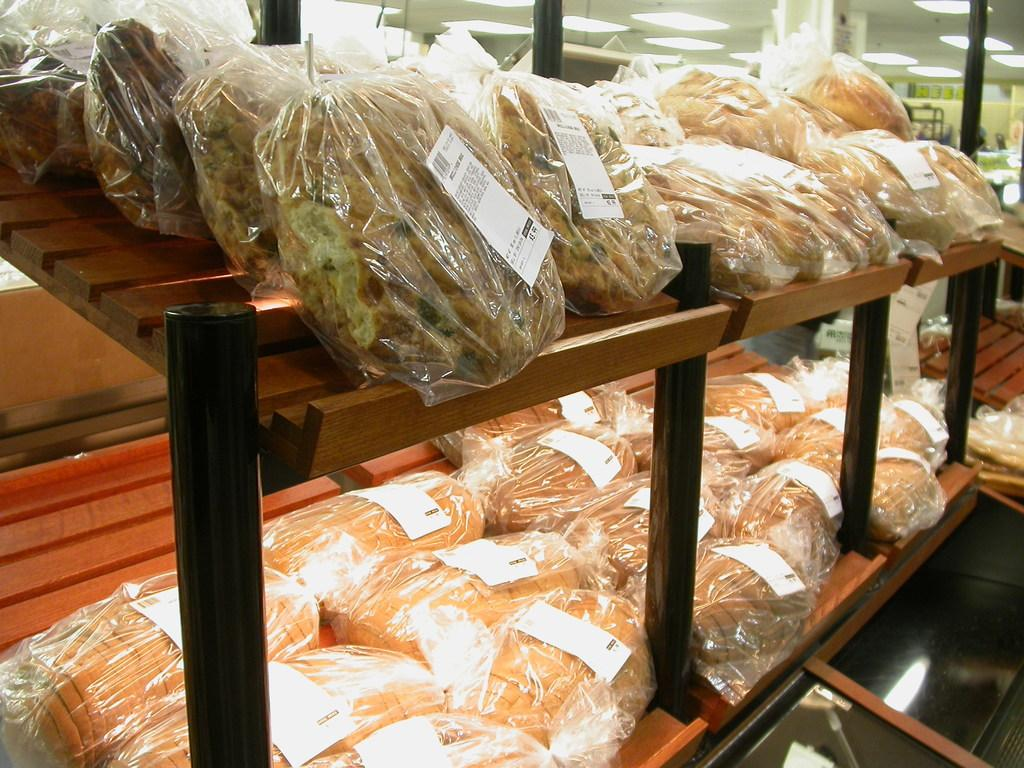What is on the rack in the image? There is a rack with food items in the image. How are the food items packaged? The food items are packed in covers. What can be seen on the food items? There are stickers on the food items. What can be seen in the background of the image? There are lights visible in the background of the image, as well as other objects. How does the crowd interact with the stick in the image? There is no crowd or stick present in the image. 